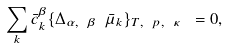Convert formula to latex. <formula><loc_0><loc_0><loc_500><loc_500>\sum _ { k } \bar { c } _ { k } ^ { \beta } \{ \Delta _ { \alpha , \ \beta \ } \bar { \mu } _ { k } \} _ { T , \ p , \ \kappa \ } = 0 ,</formula> 